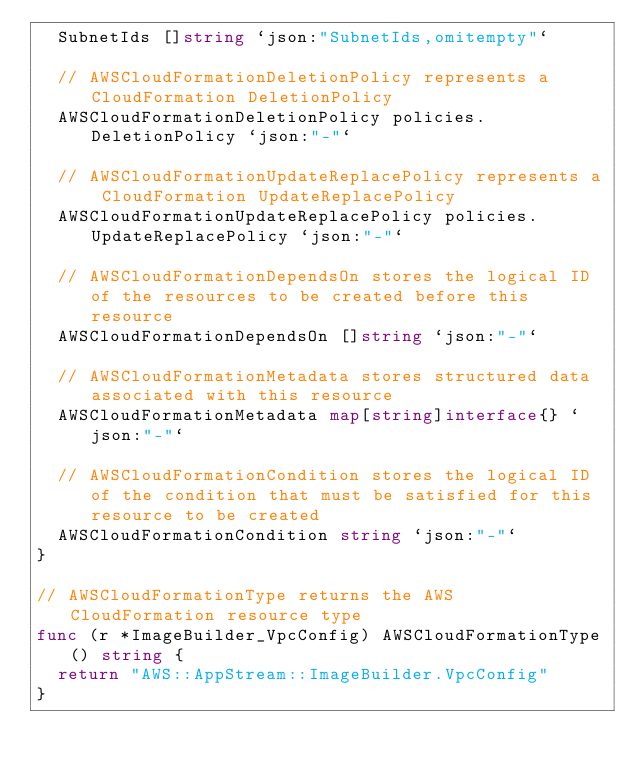<code> <loc_0><loc_0><loc_500><loc_500><_Go_>	SubnetIds []string `json:"SubnetIds,omitempty"`

	// AWSCloudFormationDeletionPolicy represents a CloudFormation DeletionPolicy
	AWSCloudFormationDeletionPolicy policies.DeletionPolicy `json:"-"`

	// AWSCloudFormationUpdateReplacePolicy represents a CloudFormation UpdateReplacePolicy
	AWSCloudFormationUpdateReplacePolicy policies.UpdateReplacePolicy `json:"-"`

	// AWSCloudFormationDependsOn stores the logical ID of the resources to be created before this resource
	AWSCloudFormationDependsOn []string `json:"-"`

	// AWSCloudFormationMetadata stores structured data associated with this resource
	AWSCloudFormationMetadata map[string]interface{} `json:"-"`

	// AWSCloudFormationCondition stores the logical ID of the condition that must be satisfied for this resource to be created
	AWSCloudFormationCondition string `json:"-"`
}

// AWSCloudFormationType returns the AWS CloudFormation resource type
func (r *ImageBuilder_VpcConfig) AWSCloudFormationType() string {
	return "AWS::AppStream::ImageBuilder.VpcConfig"
}
</code> 